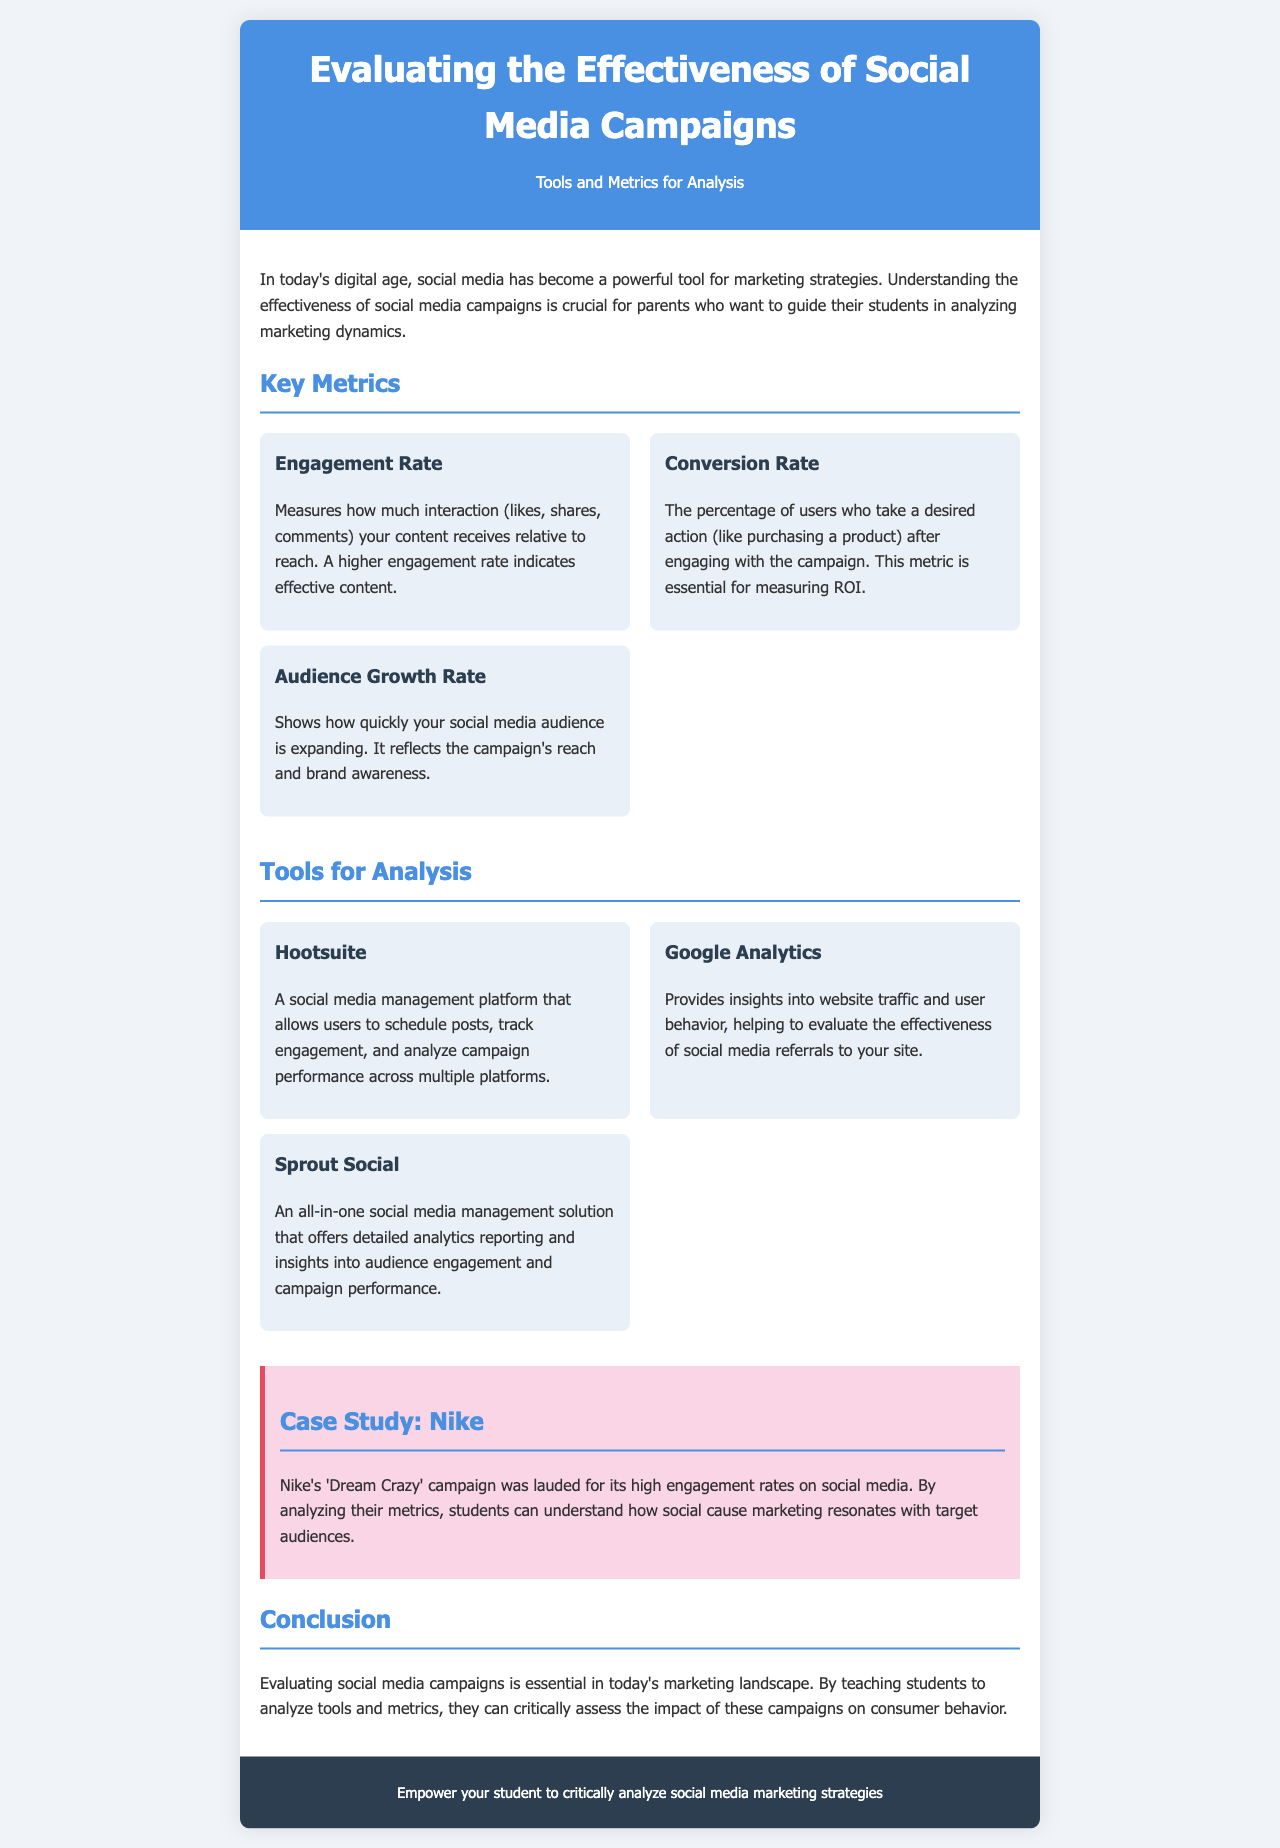What is the title of the brochure? The title is the main heading of the brochure, which introduces its subject.
Answer: Evaluating the Effectiveness of Social Media Campaigns What is the purpose of understanding the effectiveness of social media campaigns? The purpose is to provide guidance for parents to help students analyze marketing dynamics.
Answer: To guide students in analyzing marketing dynamics What metric measures audience expansion? This metric reflects the growth in social media following over time.
Answer: Audience Growth Rate Which tool tracks engagement and analyzes campaign performance? The tool is a social media management platform mentioned in the document.
Answer: Hootsuite What was the name of Nike's campaign mentioned in the case study? The name refers to a notable marketing effort by Nike recognized for high engagement.
Answer: Dream Crazy What does the conversion rate measure? This metric evaluates the proportion of users who take desired actions after engagement.
Answer: Percentage of users taking desired actions How does Nike's campaign relate to consumer behavior? The campaign offers insights into how social cause marketing impacts audience engagement.
Answer: Resonates with target audiences What type of document is this? The document serves a specific promotional and informational role, describing marketing evaluation strategies.
Answer: Brochure 